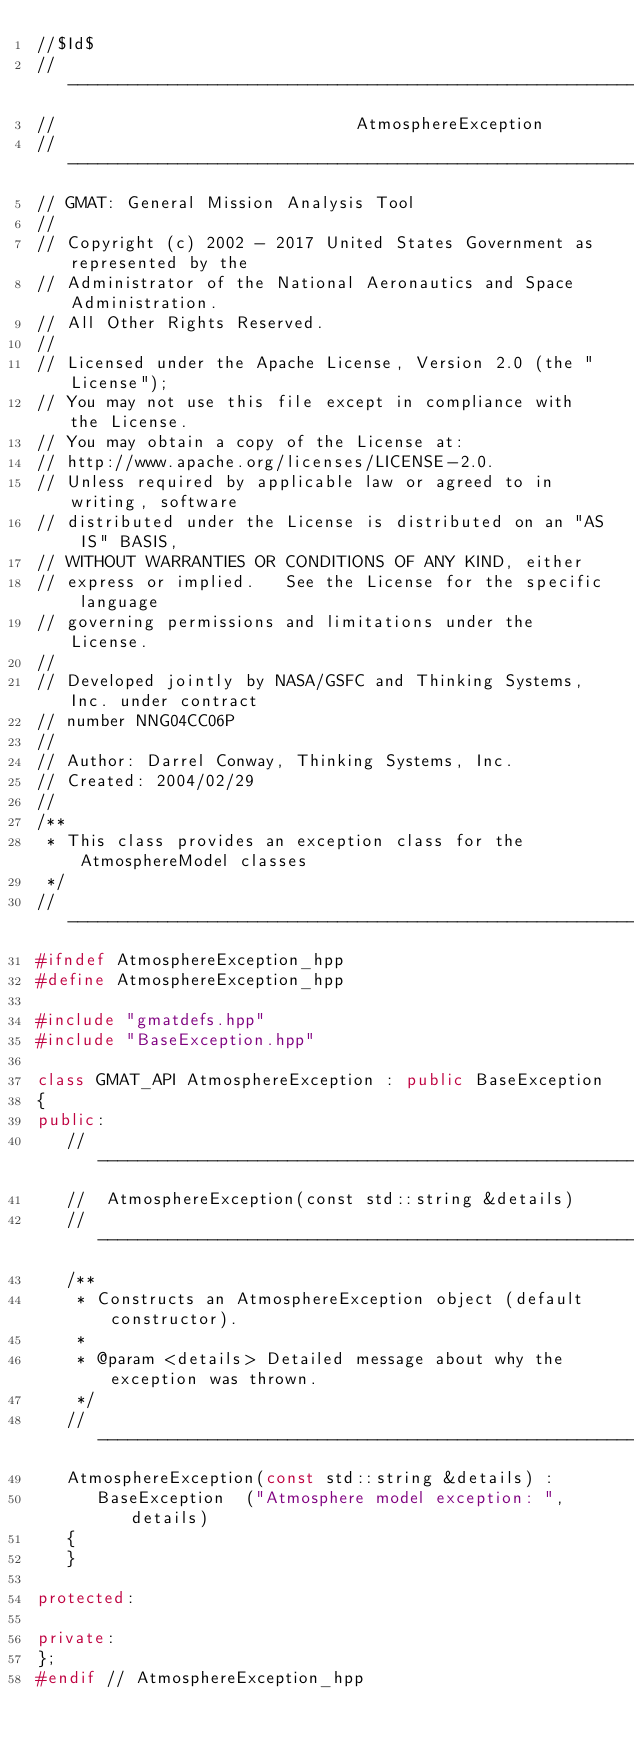<code> <loc_0><loc_0><loc_500><loc_500><_C++_>//$Id$
//------------------------------------------------------------------------------
//                              AtmosphereException
//------------------------------------------------------------------------------
// GMAT: General Mission Analysis Tool
//
// Copyright (c) 2002 - 2017 United States Government as represented by the
// Administrator of the National Aeronautics and Space Administration.
// All Other Rights Reserved.
//
// Licensed under the Apache License, Version 2.0 (the "License"); 
// You may not use this file except in compliance with the License. 
// You may obtain a copy of the License at:
// http://www.apache.org/licenses/LICENSE-2.0. 
// Unless required by applicable law or agreed to in writing, software
// distributed under the License is distributed on an "AS IS" BASIS,
// WITHOUT WARRANTIES OR CONDITIONS OF ANY KIND, either 
// express or implied.   See the License for the specific language
// governing permissions and limitations under the License.
//
// Developed jointly by NASA/GSFC and Thinking Systems, Inc. under contract
// number NNG04CC06P
//
// Author: Darrel Conway, Thinking Systems, Inc.
// Created: 2004/02/29
//
/**
 * This class provides an exception class for the AtmosphereModel classes
 */
//------------------------------------------------------------------------------
#ifndef AtmosphereException_hpp
#define AtmosphereException_hpp

#include "gmatdefs.hpp"
#include "BaseException.hpp"

class GMAT_API AtmosphereException : public BaseException
{
public:
   //---------------------------------------------------------------------------
   //  AtmosphereException(const std::string &details)
   //---------------------------------------------------------------------------
   /**
    * Constructs an AtmosphereException object (default constructor).
    *
    * @param <details> Detailed message about why the exception was thrown.
    */
   //---------------------------------------------------------------------------
   AtmosphereException(const std::string &details) :
      BaseException  ("Atmosphere model exception: ", details)
   {
   }

protected:

private:
};
#endif // AtmosphereException_hpp
</code> 